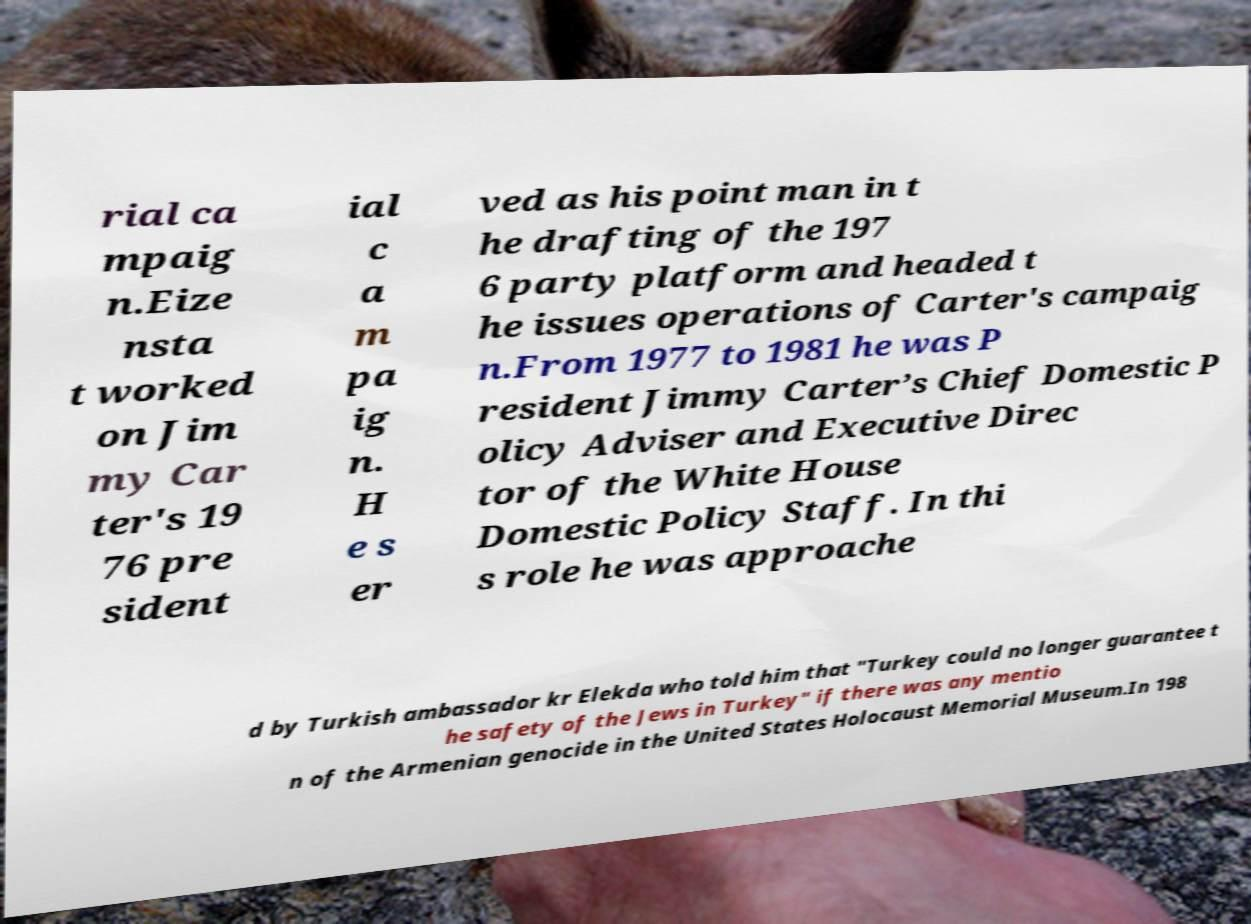Could you assist in decoding the text presented in this image and type it out clearly? rial ca mpaig n.Eize nsta t worked on Jim my Car ter's 19 76 pre sident ial c a m pa ig n. H e s er ved as his point man in t he drafting of the 197 6 party platform and headed t he issues operations of Carter's campaig n.From 1977 to 1981 he was P resident Jimmy Carter’s Chief Domestic P olicy Adviser and Executive Direc tor of the White House Domestic Policy Staff. In thi s role he was approache d by Turkish ambassador kr Elekda who told him that "Turkey could no longer guarantee t he safety of the Jews in Turkey" if there was any mentio n of the Armenian genocide in the United States Holocaust Memorial Museum.In 198 